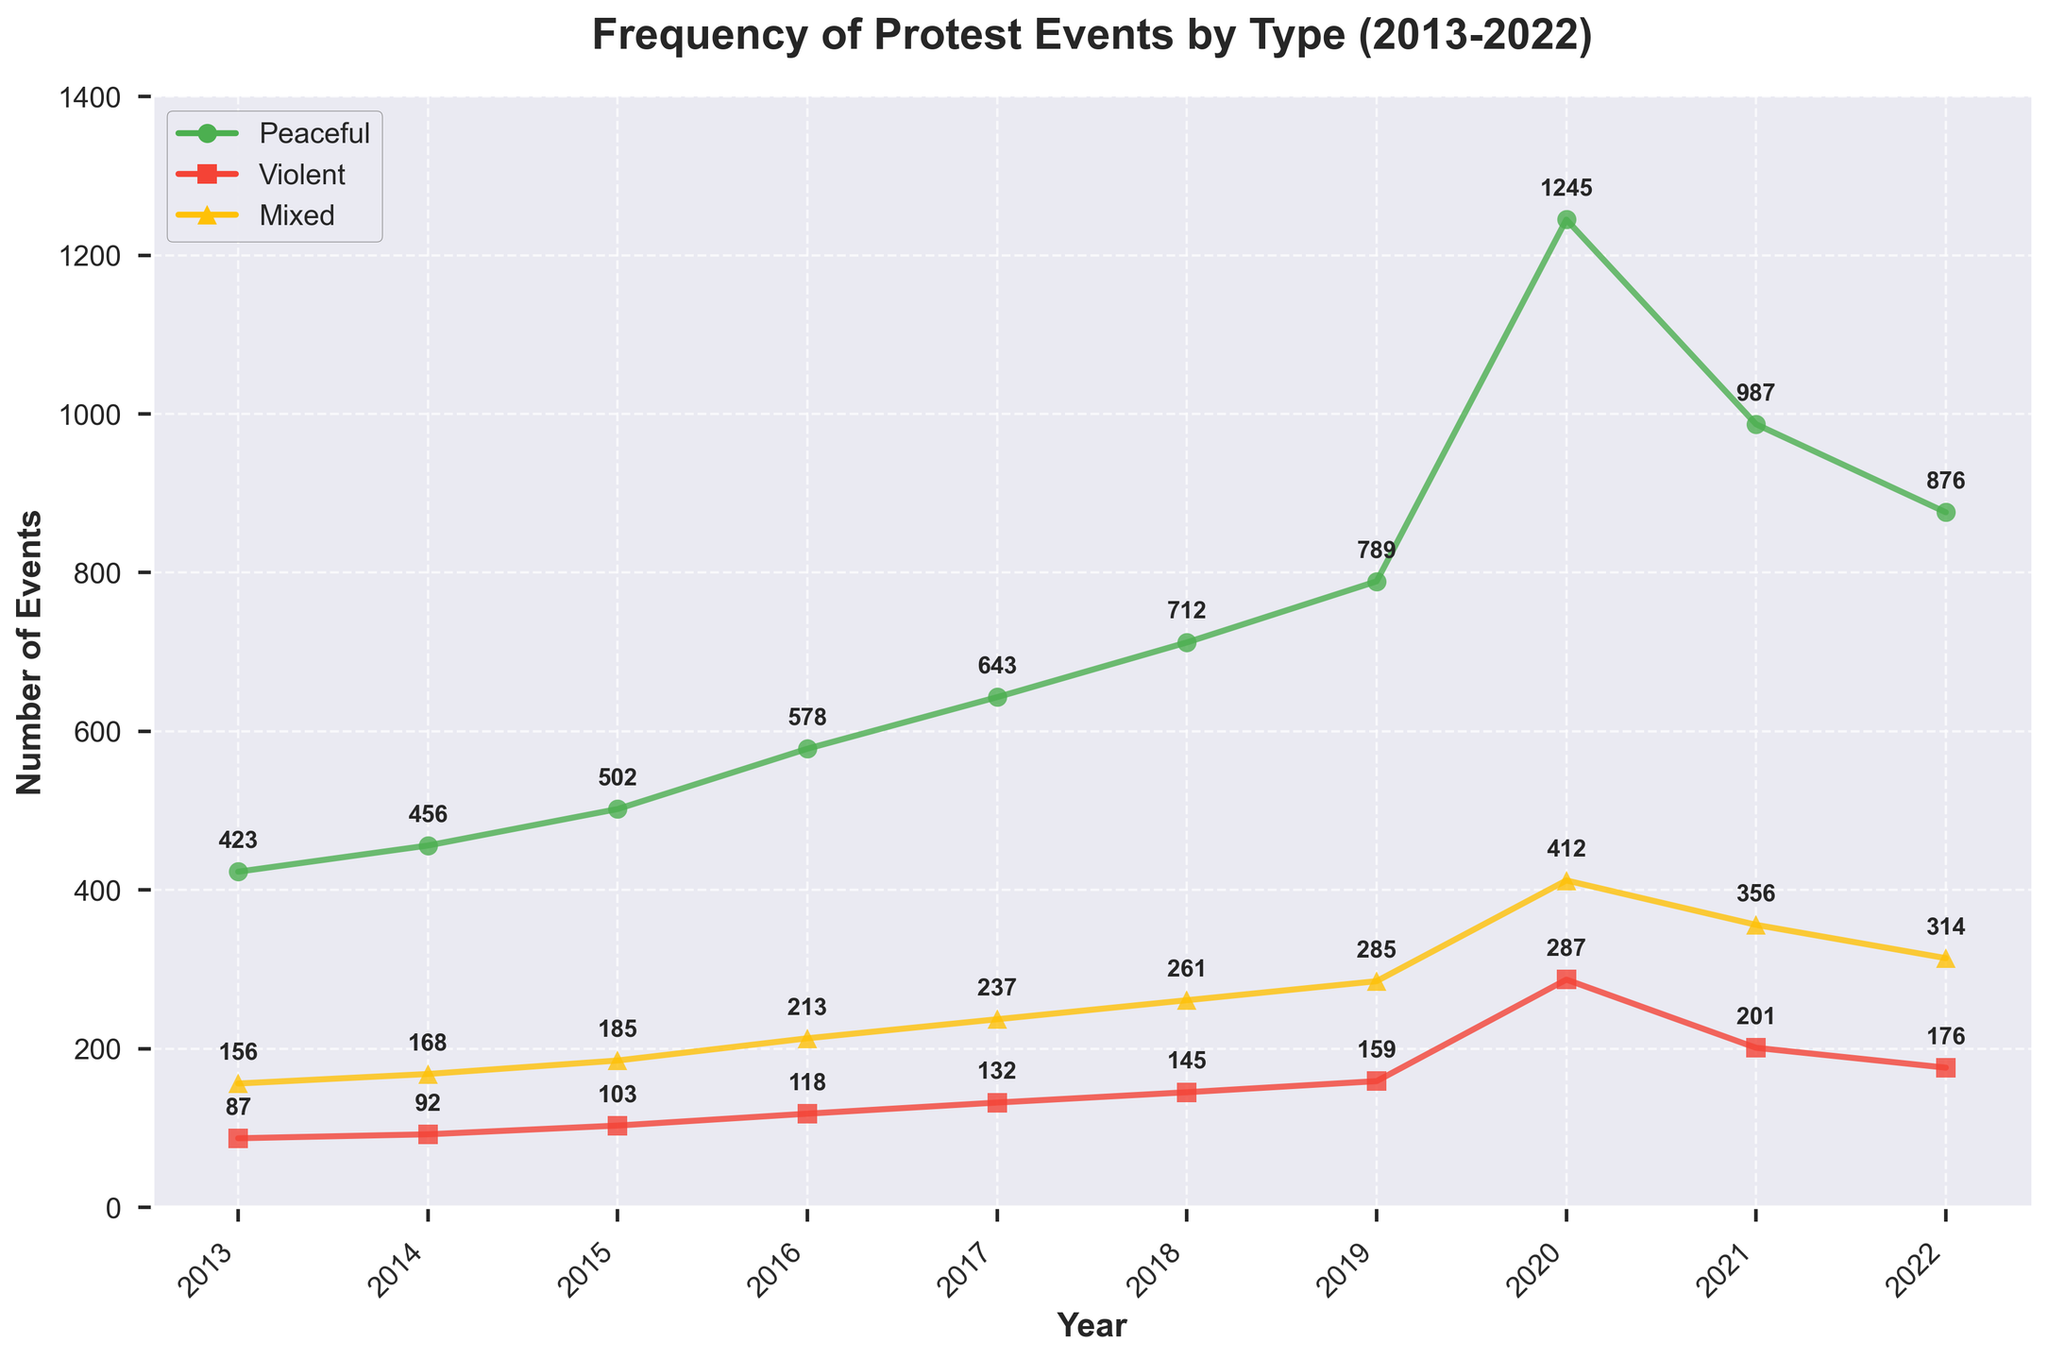Which year had the highest number of peaceful protests? Referring to the figure, locate the peak of the green line, which represents peaceful protests. The peak occurs in 2020 with 1245 events.
Answer: 2020 How did the number of violent protests change from 2019 to 2020? Identify the red line's values for 2019 and 2020. In 2019, there were 159 violent protests, and in 2020, there were 287. The change is calculated as 287 - 159.
Answer: Increased by 128 Which type of protest saw the most consistent increase over the decade? Observe the trend lines for each type of protest. The green line (peaceful protests) shows a steady and consistent increase.
Answer: Peaceful What is the total number of mixed protests in 2022? Check the yellow line's label in 2022. The number of mixed protests is 314.
Answer: 314 What was the average number of peaceful protests over the decade? Sum the values for peaceful protests from 2013 to 2022: (423 + 456 + 502 + 578 + 643 + 712 + 789 + 1245 + 987 + 876). Divide the total by the number of years (10). The calculation is (7211 / 10).
Answer: 721.1 In which year did mixed protests exceed violent protests the most? Compare the differences between the yellow and red lines for each year and identify where the difference was greatest. In 2020, mixed protests (412) exceeded violent protests (287) by 125, the largest margin.
Answer: 2020 How does the lowest number of peaceful protests compare with the highest number of violent protests? Identify the lowest value in the green line (423 in 2013) and the highest value in the red line (287 in 2020), then compare these values.
Answer: Lowest peaceful: 423; Highest violent: 287 Which year exhibited the largest overall number of protest events (sum of peaceful, violent, mixed)? Add the values of all types of protests for each year. 2020 shows the largest sum: 1245 (peaceful) + 287 (violent) + 412 (mixed) = 1944.
Answer: 2020 How did the number of mixed protests in 2018 compare to the number of violent protests in the same year? Locate the values for mixed (yellow line) and violent (red line) protests in 2018. Mixed protests were 261 and violent protests were 145. Compare these values.
Answer: Mixed were 116 more than violent What trend can be seen in violent protests from 2018 to 2022? Observe the red line from 2018 (145) to 2022 (176). The trend shows a peak in 2020 (287) followed by a decrease
Answer: Peaked in 2020, then decreased 